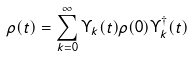Convert formula to latex. <formula><loc_0><loc_0><loc_500><loc_500>\rho ( t ) = \sum _ { k = 0 } ^ { \infty } \Upsilon _ { k } ( t ) \rho ( 0 ) \Upsilon ^ { \dagger } _ { k } ( t )</formula> 